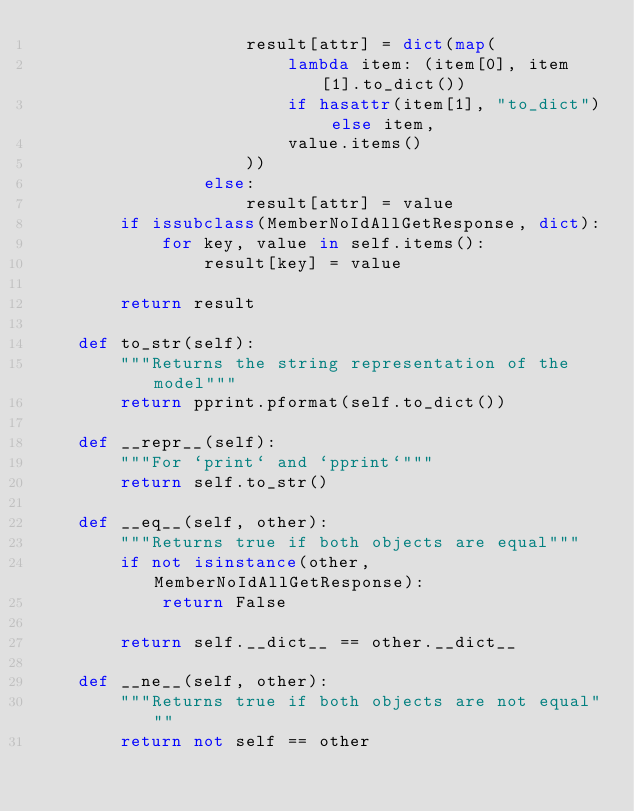Convert code to text. <code><loc_0><loc_0><loc_500><loc_500><_Python_>                    result[attr] = dict(map(
                        lambda item: (item[0], item[1].to_dict())
                        if hasattr(item[1], "to_dict") else item,
                        value.items()
                    ))
                else:
                    result[attr] = value
        if issubclass(MemberNoIdAllGetResponse, dict):
            for key, value in self.items():
                result[key] = value

        return result

    def to_str(self):
        """Returns the string representation of the model"""
        return pprint.pformat(self.to_dict())

    def __repr__(self):
        """For `print` and `pprint`"""
        return self.to_str()

    def __eq__(self, other):
        """Returns true if both objects are equal"""
        if not isinstance(other, MemberNoIdAllGetResponse):
            return False

        return self.__dict__ == other.__dict__

    def __ne__(self, other):
        """Returns true if both objects are not equal"""
        return not self == other
</code> 